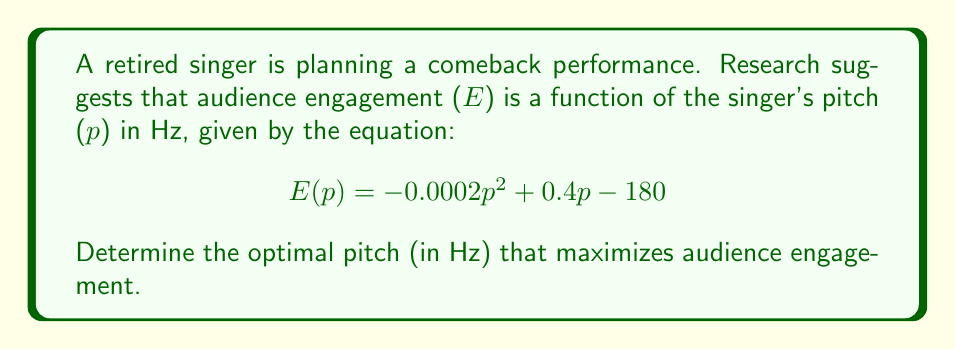Help me with this question. To find the optimal pitch that maximizes audience engagement, we need to find the maximum of the function E(p). We can do this by following these steps:

1. Find the derivative of E(p) with respect to p:
   $$\frac{d}{dp}E(p) = -0.0004p + 0.4$$

2. Set the derivative equal to zero to find the critical point:
   $$-0.0004p + 0.4 = 0$$

3. Solve for p:
   $$-0.0004p = -0.4$$
   $$p = \frac{-0.4}{-0.0004} = 1000$$

4. Verify that this critical point is a maximum by checking the second derivative:
   $$\frac{d^2}{dp^2}E(p) = -0.0004$$

   Since the second derivative is negative, the critical point is a maximum.

5. Therefore, the optimal pitch that maximizes audience engagement is 1000 Hz.

This pitch corresponds to approximately a high C (C6) in musical notation, which is within the typical range of a soprano voice. For a retired singer, this pitch might be challenging but could showcase their vocal prowess and engage the audience effectively.
Answer: 1000 Hz 